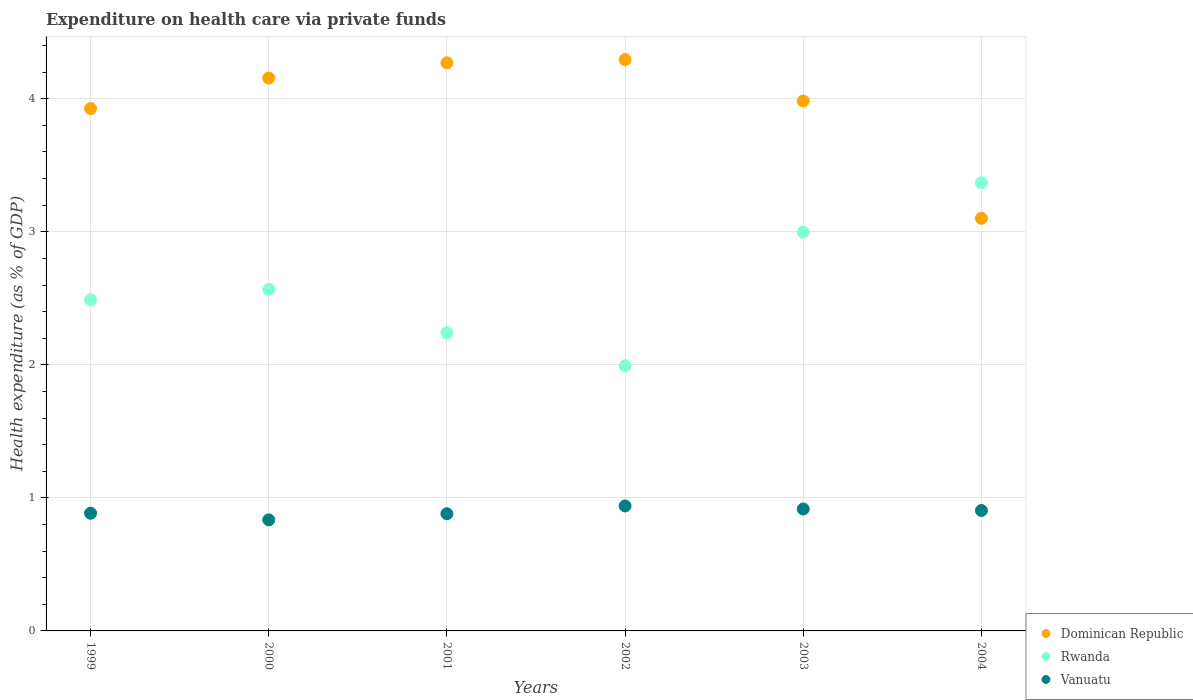Is the number of dotlines equal to the number of legend labels?
Offer a terse response. Yes. What is the expenditure made on health care in Rwanda in 2003?
Provide a short and direct response. 3. Across all years, what is the maximum expenditure made on health care in Dominican Republic?
Give a very brief answer. 4.29. Across all years, what is the minimum expenditure made on health care in Rwanda?
Give a very brief answer. 1.99. What is the total expenditure made on health care in Rwanda in the graph?
Keep it short and to the point. 15.66. What is the difference between the expenditure made on health care in Dominican Republic in 1999 and that in 2004?
Provide a short and direct response. 0.82. What is the difference between the expenditure made on health care in Dominican Republic in 2003 and the expenditure made on health care in Rwanda in 2000?
Make the answer very short. 1.42. What is the average expenditure made on health care in Rwanda per year?
Give a very brief answer. 2.61. In the year 1999, what is the difference between the expenditure made on health care in Dominican Republic and expenditure made on health care in Rwanda?
Give a very brief answer. 1.44. What is the ratio of the expenditure made on health care in Rwanda in 1999 to that in 2004?
Give a very brief answer. 0.74. Is the expenditure made on health care in Vanuatu in 2000 less than that in 2003?
Ensure brevity in your answer.  Yes. Is the difference between the expenditure made on health care in Dominican Republic in 2001 and 2003 greater than the difference between the expenditure made on health care in Rwanda in 2001 and 2003?
Provide a short and direct response. Yes. What is the difference between the highest and the second highest expenditure made on health care in Rwanda?
Provide a short and direct response. 0.37. What is the difference between the highest and the lowest expenditure made on health care in Vanuatu?
Provide a short and direct response. 0.1. Is the sum of the expenditure made on health care in Vanuatu in 1999 and 2003 greater than the maximum expenditure made on health care in Rwanda across all years?
Provide a short and direct response. No. Is the expenditure made on health care in Dominican Republic strictly greater than the expenditure made on health care in Vanuatu over the years?
Your answer should be compact. Yes. How many dotlines are there?
Offer a very short reply. 3. How many years are there in the graph?
Offer a very short reply. 6. What is the difference between two consecutive major ticks on the Y-axis?
Give a very brief answer. 1. Are the values on the major ticks of Y-axis written in scientific E-notation?
Your answer should be compact. No. Where does the legend appear in the graph?
Make the answer very short. Bottom right. What is the title of the graph?
Your answer should be compact. Expenditure on health care via private funds. Does "Monaco" appear as one of the legend labels in the graph?
Your response must be concise. No. What is the label or title of the Y-axis?
Offer a very short reply. Health expenditure (as % of GDP). What is the Health expenditure (as % of GDP) in Dominican Republic in 1999?
Keep it short and to the point. 3.93. What is the Health expenditure (as % of GDP) of Rwanda in 1999?
Ensure brevity in your answer.  2.49. What is the Health expenditure (as % of GDP) in Vanuatu in 1999?
Offer a very short reply. 0.88. What is the Health expenditure (as % of GDP) in Dominican Republic in 2000?
Offer a very short reply. 4.16. What is the Health expenditure (as % of GDP) in Rwanda in 2000?
Provide a short and direct response. 2.57. What is the Health expenditure (as % of GDP) of Vanuatu in 2000?
Provide a short and direct response. 0.83. What is the Health expenditure (as % of GDP) in Dominican Republic in 2001?
Provide a short and direct response. 4.27. What is the Health expenditure (as % of GDP) of Rwanda in 2001?
Give a very brief answer. 2.24. What is the Health expenditure (as % of GDP) in Vanuatu in 2001?
Your response must be concise. 0.88. What is the Health expenditure (as % of GDP) of Dominican Republic in 2002?
Provide a succinct answer. 4.29. What is the Health expenditure (as % of GDP) of Rwanda in 2002?
Give a very brief answer. 1.99. What is the Health expenditure (as % of GDP) of Vanuatu in 2002?
Your response must be concise. 0.94. What is the Health expenditure (as % of GDP) of Dominican Republic in 2003?
Your answer should be very brief. 3.98. What is the Health expenditure (as % of GDP) in Rwanda in 2003?
Your answer should be very brief. 3. What is the Health expenditure (as % of GDP) in Vanuatu in 2003?
Your answer should be very brief. 0.92. What is the Health expenditure (as % of GDP) in Dominican Republic in 2004?
Provide a short and direct response. 3.1. What is the Health expenditure (as % of GDP) in Rwanda in 2004?
Ensure brevity in your answer.  3.37. What is the Health expenditure (as % of GDP) in Vanuatu in 2004?
Provide a succinct answer. 0.91. Across all years, what is the maximum Health expenditure (as % of GDP) in Dominican Republic?
Give a very brief answer. 4.29. Across all years, what is the maximum Health expenditure (as % of GDP) of Rwanda?
Ensure brevity in your answer.  3.37. Across all years, what is the maximum Health expenditure (as % of GDP) in Vanuatu?
Ensure brevity in your answer.  0.94. Across all years, what is the minimum Health expenditure (as % of GDP) of Dominican Republic?
Provide a short and direct response. 3.1. Across all years, what is the minimum Health expenditure (as % of GDP) of Rwanda?
Your answer should be compact. 1.99. Across all years, what is the minimum Health expenditure (as % of GDP) of Vanuatu?
Give a very brief answer. 0.83. What is the total Health expenditure (as % of GDP) in Dominican Republic in the graph?
Your response must be concise. 23.73. What is the total Health expenditure (as % of GDP) in Rwanda in the graph?
Provide a succinct answer. 15.66. What is the total Health expenditure (as % of GDP) of Vanuatu in the graph?
Provide a succinct answer. 5.36. What is the difference between the Health expenditure (as % of GDP) of Dominican Republic in 1999 and that in 2000?
Provide a short and direct response. -0.23. What is the difference between the Health expenditure (as % of GDP) of Rwanda in 1999 and that in 2000?
Provide a short and direct response. -0.08. What is the difference between the Health expenditure (as % of GDP) in Vanuatu in 1999 and that in 2000?
Give a very brief answer. 0.05. What is the difference between the Health expenditure (as % of GDP) of Dominican Republic in 1999 and that in 2001?
Your response must be concise. -0.34. What is the difference between the Health expenditure (as % of GDP) of Rwanda in 1999 and that in 2001?
Offer a terse response. 0.25. What is the difference between the Health expenditure (as % of GDP) of Vanuatu in 1999 and that in 2001?
Provide a short and direct response. 0. What is the difference between the Health expenditure (as % of GDP) of Dominican Republic in 1999 and that in 2002?
Offer a terse response. -0.37. What is the difference between the Health expenditure (as % of GDP) of Rwanda in 1999 and that in 2002?
Provide a short and direct response. 0.5. What is the difference between the Health expenditure (as % of GDP) in Vanuatu in 1999 and that in 2002?
Your answer should be compact. -0.05. What is the difference between the Health expenditure (as % of GDP) in Dominican Republic in 1999 and that in 2003?
Your answer should be very brief. -0.06. What is the difference between the Health expenditure (as % of GDP) in Rwanda in 1999 and that in 2003?
Provide a succinct answer. -0.51. What is the difference between the Health expenditure (as % of GDP) of Vanuatu in 1999 and that in 2003?
Provide a succinct answer. -0.03. What is the difference between the Health expenditure (as % of GDP) of Dominican Republic in 1999 and that in 2004?
Keep it short and to the point. 0.82. What is the difference between the Health expenditure (as % of GDP) of Rwanda in 1999 and that in 2004?
Give a very brief answer. -0.88. What is the difference between the Health expenditure (as % of GDP) of Vanuatu in 1999 and that in 2004?
Provide a short and direct response. -0.02. What is the difference between the Health expenditure (as % of GDP) of Dominican Republic in 2000 and that in 2001?
Your answer should be very brief. -0.11. What is the difference between the Health expenditure (as % of GDP) in Rwanda in 2000 and that in 2001?
Ensure brevity in your answer.  0.33. What is the difference between the Health expenditure (as % of GDP) of Vanuatu in 2000 and that in 2001?
Offer a very short reply. -0.05. What is the difference between the Health expenditure (as % of GDP) in Dominican Republic in 2000 and that in 2002?
Give a very brief answer. -0.14. What is the difference between the Health expenditure (as % of GDP) in Rwanda in 2000 and that in 2002?
Ensure brevity in your answer.  0.57. What is the difference between the Health expenditure (as % of GDP) of Vanuatu in 2000 and that in 2002?
Keep it short and to the point. -0.1. What is the difference between the Health expenditure (as % of GDP) of Dominican Republic in 2000 and that in 2003?
Your answer should be compact. 0.17. What is the difference between the Health expenditure (as % of GDP) in Rwanda in 2000 and that in 2003?
Your answer should be compact. -0.43. What is the difference between the Health expenditure (as % of GDP) of Vanuatu in 2000 and that in 2003?
Give a very brief answer. -0.08. What is the difference between the Health expenditure (as % of GDP) in Dominican Republic in 2000 and that in 2004?
Your answer should be compact. 1.05. What is the difference between the Health expenditure (as % of GDP) of Rwanda in 2000 and that in 2004?
Ensure brevity in your answer.  -0.8. What is the difference between the Health expenditure (as % of GDP) in Vanuatu in 2000 and that in 2004?
Ensure brevity in your answer.  -0.07. What is the difference between the Health expenditure (as % of GDP) of Dominican Republic in 2001 and that in 2002?
Your answer should be compact. -0.02. What is the difference between the Health expenditure (as % of GDP) in Rwanda in 2001 and that in 2002?
Give a very brief answer. 0.25. What is the difference between the Health expenditure (as % of GDP) in Vanuatu in 2001 and that in 2002?
Offer a very short reply. -0.06. What is the difference between the Health expenditure (as % of GDP) in Dominican Republic in 2001 and that in 2003?
Make the answer very short. 0.29. What is the difference between the Health expenditure (as % of GDP) of Rwanda in 2001 and that in 2003?
Your answer should be compact. -0.76. What is the difference between the Health expenditure (as % of GDP) of Vanuatu in 2001 and that in 2003?
Keep it short and to the point. -0.04. What is the difference between the Health expenditure (as % of GDP) of Dominican Republic in 2001 and that in 2004?
Give a very brief answer. 1.17. What is the difference between the Health expenditure (as % of GDP) of Rwanda in 2001 and that in 2004?
Ensure brevity in your answer.  -1.13. What is the difference between the Health expenditure (as % of GDP) of Vanuatu in 2001 and that in 2004?
Make the answer very short. -0.02. What is the difference between the Health expenditure (as % of GDP) in Dominican Republic in 2002 and that in 2003?
Offer a very short reply. 0.31. What is the difference between the Health expenditure (as % of GDP) of Rwanda in 2002 and that in 2003?
Give a very brief answer. -1. What is the difference between the Health expenditure (as % of GDP) in Vanuatu in 2002 and that in 2003?
Give a very brief answer. 0.02. What is the difference between the Health expenditure (as % of GDP) in Dominican Republic in 2002 and that in 2004?
Give a very brief answer. 1.19. What is the difference between the Health expenditure (as % of GDP) in Rwanda in 2002 and that in 2004?
Your response must be concise. -1.38. What is the difference between the Health expenditure (as % of GDP) in Vanuatu in 2002 and that in 2004?
Provide a short and direct response. 0.03. What is the difference between the Health expenditure (as % of GDP) of Dominican Republic in 2003 and that in 2004?
Provide a succinct answer. 0.88. What is the difference between the Health expenditure (as % of GDP) of Rwanda in 2003 and that in 2004?
Give a very brief answer. -0.37. What is the difference between the Health expenditure (as % of GDP) of Vanuatu in 2003 and that in 2004?
Your answer should be compact. 0.01. What is the difference between the Health expenditure (as % of GDP) in Dominican Republic in 1999 and the Health expenditure (as % of GDP) in Rwanda in 2000?
Make the answer very short. 1.36. What is the difference between the Health expenditure (as % of GDP) in Dominican Republic in 1999 and the Health expenditure (as % of GDP) in Vanuatu in 2000?
Provide a short and direct response. 3.09. What is the difference between the Health expenditure (as % of GDP) of Rwanda in 1999 and the Health expenditure (as % of GDP) of Vanuatu in 2000?
Keep it short and to the point. 1.65. What is the difference between the Health expenditure (as % of GDP) in Dominican Republic in 1999 and the Health expenditure (as % of GDP) in Rwanda in 2001?
Make the answer very short. 1.69. What is the difference between the Health expenditure (as % of GDP) in Dominican Republic in 1999 and the Health expenditure (as % of GDP) in Vanuatu in 2001?
Ensure brevity in your answer.  3.05. What is the difference between the Health expenditure (as % of GDP) of Rwanda in 1999 and the Health expenditure (as % of GDP) of Vanuatu in 2001?
Provide a short and direct response. 1.61. What is the difference between the Health expenditure (as % of GDP) of Dominican Republic in 1999 and the Health expenditure (as % of GDP) of Rwanda in 2002?
Your response must be concise. 1.93. What is the difference between the Health expenditure (as % of GDP) in Dominican Republic in 1999 and the Health expenditure (as % of GDP) in Vanuatu in 2002?
Provide a short and direct response. 2.99. What is the difference between the Health expenditure (as % of GDP) of Rwanda in 1999 and the Health expenditure (as % of GDP) of Vanuatu in 2002?
Offer a terse response. 1.55. What is the difference between the Health expenditure (as % of GDP) of Dominican Republic in 1999 and the Health expenditure (as % of GDP) of Rwanda in 2003?
Make the answer very short. 0.93. What is the difference between the Health expenditure (as % of GDP) in Dominican Republic in 1999 and the Health expenditure (as % of GDP) in Vanuatu in 2003?
Provide a short and direct response. 3.01. What is the difference between the Health expenditure (as % of GDP) of Rwanda in 1999 and the Health expenditure (as % of GDP) of Vanuatu in 2003?
Provide a succinct answer. 1.57. What is the difference between the Health expenditure (as % of GDP) of Dominican Republic in 1999 and the Health expenditure (as % of GDP) of Rwanda in 2004?
Your response must be concise. 0.56. What is the difference between the Health expenditure (as % of GDP) of Dominican Republic in 1999 and the Health expenditure (as % of GDP) of Vanuatu in 2004?
Ensure brevity in your answer.  3.02. What is the difference between the Health expenditure (as % of GDP) of Rwanda in 1999 and the Health expenditure (as % of GDP) of Vanuatu in 2004?
Ensure brevity in your answer.  1.58. What is the difference between the Health expenditure (as % of GDP) in Dominican Republic in 2000 and the Health expenditure (as % of GDP) in Rwanda in 2001?
Your answer should be very brief. 1.91. What is the difference between the Health expenditure (as % of GDP) of Dominican Republic in 2000 and the Health expenditure (as % of GDP) of Vanuatu in 2001?
Provide a short and direct response. 3.27. What is the difference between the Health expenditure (as % of GDP) of Rwanda in 2000 and the Health expenditure (as % of GDP) of Vanuatu in 2001?
Provide a short and direct response. 1.69. What is the difference between the Health expenditure (as % of GDP) in Dominican Republic in 2000 and the Health expenditure (as % of GDP) in Rwanda in 2002?
Provide a short and direct response. 2.16. What is the difference between the Health expenditure (as % of GDP) of Dominican Republic in 2000 and the Health expenditure (as % of GDP) of Vanuatu in 2002?
Provide a short and direct response. 3.22. What is the difference between the Health expenditure (as % of GDP) in Rwanda in 2000 and the Health expenditure (as % of GDP) in Vanuatu in 2002?
Ensure brevity in your answer.  1.63. What is the difference between the Health expenditure (as % of GDP) of Dominican Republic in 2000 and the Health expenditure (as % of GDP) of Rwanda in 2003?
Ensure brevity in your answer.  1.16. What is the difference between the Health expenditure (as % of GDP) in Dominican Republic in 2000 and the Health expenditure (as % of GDP) in Vanuatu in 2003?
Your answer should be compact. 3.24. What is the difference between the Health expenditure (as % of GDP) of Rwanda in 2000 and the Health expenditure (as % of GDP) of Vanuatu in 2003?
Offer a very short reply. 1.65. What is the difference between the Health expenditure (as % of GDP) in Dominican Republic in 2000 and the Health expenditure (as % of GDP) in Rwanda in 2004?
Your answer should be compact. 0.79. What is the difference between the Health expenditure (as % of GDP) in Dominican Republic in 2000 and the Health expenditure (as % of GDP) in Vanuatu in 2004?
Your response must be concise. 3.25. What is the difference between the Health expenditure (as % of GDP) of Rwanda in 2000 and the Health expenditure (as % of GDP) of Vanuatu in 2004?
Make the answer very short. 1.66. What is the difference between the Health expenditure (as % of GDP) of Dominican Republic in 2001 and the Health expenditure (as % of GDP) of Rwanda in 2002?
Your answer should be very brief. 2.28. What is the difference between the Health expenditure (as % of GDP) of Dominican Republic in 2001 and the Health expenditure (as % of GDP) of Vanuatu in 2002?
Your response must be concise. 3.33. What is the difference between the Health expenditure (as % of GDP) of Rwanda in 2001 and the Health expenditure (as % of GDP) of Vanuatu in 2002?
Keep it short and to the point. 1.3. What is the difference between the Health expenditure (as % of GDP) in Dominican Republic in 2001 and the Health expenditure (as % of GDP) in Rwanda in 2003?
Make the answer very short. 1.27. What is the difference between the Health expenditure (as % of GDP) in Dominican Republic in 2001 and the Health expenditure (as % of GDP) in Vanuatu in 2003?
Offer a terse response. 3.35. What is the difference between the Health expenditure (as % of GDP) in Rwanda in 2001 and the Health expenditure (as % of GDP) in Vanuatu in 2003?
Keep it short and to the point. 1.32. What is the difference between the Health expenditure (as % of GDP) in Dominican Republic in 2001 and the Health expenditure (as % of GDP) in Rwanda in 2004?
Your response must be concise. 0.9. What is the difference between the Health expenditure (as % of GDP) in Dominican Republic in 2001 and the Health expenditure (as % of GDP) in Vanuatu in 2004?
Provide a short and direct response. 3.37. What is the difference between the Health expenditure (as % of GDP) of Rwanda in 2001 and the Health expenditure (as % of GDP) of Vanuatu in 2004?
Offer a very short reply. 1.34. What is the difference between the Health expenditure (as % of GDP) of Dominican Republic in 2002 and the Health expenditure (as % of GDP) of Rwanda in 2003?
Your answer should be compact. 1.3. What is the difference between the Health expenditure (as % of GDP) of Dominican Republic in 2002 and the Health expenditure (as % of GDP) of Vanuatu in 2003?
Ensure brevity in your answer.  3.38. What is the difference between the Health expenditure (as % of GDP) of Rwanda in 2002 and the Health expenditure (as % of GDP) of Vanuatu in 2003?
Your response must be concise. 1.08. What is the difference between the Health expenditure (as % of GDP) in Dominican Republic in 2002 and the Health expenditure (as % of GDP) in Rwanda in 2004?
Ensure brevity in your answer.  0.93. What is the difference between the Health expenditure (as % of GDP) in Dominican Republic in 2002 and the Health expenditure (as % of GDP) in Vanuatu in 2004?
Make the answer very short. 3.39. What is the difference between the Health expenditure (as % of GDP) of Rwanda in 2002 and the Health expenditure (as % of GDP) of Vanuatu in 2004?
Your response must be concise. 1.09. What is the difference between the Health expenditure (as % of GDP) in Dominican Republic in 2003 and the Health expenditure (as % of GDP) in Rwanda in 2004?
Offer a very short reply. 0.61. What is the difference between the Health expenditure (as % of GDP) in Dominican Republic in 2003 and the Health expenditure (as % of GDP) in Vanuatu in 2004?
Make the answer very short. 3.08. What is the difference between the Health expenditure (as % of GDP) in Rwanda in 2003 and the Health expenditure (as % of GDP) in Vanuatu in 2004?
Offer a very short reply. 2.09. What is the average Health expenditure (as % of GDP) in Dominican Republic per year?
Your answer should be compact. 3.96. What is the average Health expenditure (as % of GDP) of Rwanda per year?
Make the answer very short. 2.61. What is the average Health expenditure (as % of GDP) of Vanuatu per year?
Your answer should be compact. 0.89. In the year 1999, what is the difference between the Health expenditure (as % of GDP) in Dominican Republic and Health expenditure (as % of GDP) in Rwanda?
Make the answer very short. 1.44. In the year 1999, what is the difference between the Health expenditure (as % of GDP) of Dominican Republic and Health expenditure (as % of GDP) of Vanuatu?
Make the answer very short. 3.04. In the year 1999, what is the difference between the Health expenditure (as % of GDP) of Rwanda and Health expenditure (as % of GDP) of Vanuatu?
Your answer should be very brief. 1.6. In the year 2000, what is the difference between the Health expenditure (as % of GDP) in Dominican Republic and Health expenditure (as % of GDP) in Rwanda?
Provide a short and direct response. 1.59. In the year 2000, what is the difference between the Health expenditure (as % of GDP) in Dominican Republic and Health expenditure (as % of GDP) in Vanuatu?
Offer a very short reply. 3.32. In the year 2000, what is the difference between the Health expenditure (as % of GDP) of Rwanda and Health expenditure (as % of GDP) of Vanuatu?
Offer a very short reply. 1.73. In the year 2001, what is the difference between the Health expenditure (as % of GDP) in Dominican Republic and Health expenditure (as % of GDP) in Rwanda?
Give a very brief answer. 2.03. In the year 2001, what is the difference between the Health expenditure (as % of GDP) of Dominican Republic and Health expenditure (as % of GDP) of Vanuatu?
Your answer should be very brief. 3.39. In the year 2001, what is the difference between the Health expenditure (as % of GDP) of Rwanda and Health expenditure (as % of GDP) of Vanuatu?
Ensure brevity in your answer.  1.36. In the year 2002, what is the difference between the Health expenditure (as % of GDP) in Dominican Republic and Health expenditure (as % of GDP) in Rwanda?
Offer a terse response. 2.3. In the year 2002, what is the difference between the Health expenditure (as % of GDP) of Dominican Republic and Health expenditure (as % of GDP) of Vanuatu?
Ensure brevity in your answer.  3.36. In the year 2002, what is the difference between the Health expenditure (as % of GDP) of Rwanda and Health expenditure (as % of GDP) of Vanuatu?
Your response must be concise. 1.05. In the year 2003, what is the difference between the Health expenditure (as % of GDP) of Dominican Republic and Health expenditure (as % of GDP) of Rwanda?
Provide a succinct answer. 0.99. In the year 2003, what is the difference between the Health expenditure (as % of GDP) in Dominican Republic and Health expenditure (as % of GDP) in Vanuatu?
Give a very brief answer. 3.07. In the year 2003, what is the difference between the Health expenditure (as % of GDP) of Rwanda and Health expenditure (as % of GDP) of Vanuatu?
Your answer should be very brief. 2.08. In the year 2004, what is the difference between the Health expenditure (as % of GDP) in Dominican Republic and Health expenditure (as % of GDP) in Rwanda?
Provide a short and direct response. -0.27. In the year 2004, what is the difference between the Health expenditure (as % of GDP) in Dominican Republic and Health expenditure (as % of GDP) in Vanuatu?
Provide a succinct answer. 2.2. In the year 2004, what is the difference between the Health expenditure (as % of GDP) in Rwanda and Health expenditure (as % of GDP) in Vanuatu?
Your answer should be very brief. 2.46. What is the ratio of the Health expenditure (as % of GDP) in Dominican Republic in 1999 to that in 2000?
Offer a very short reply. 0.94. What is the ratio of the Health expenditure (as % of GDP) of Rwanda in 1999 to that in 2000?
Provide a succinct answer. 0.97. What is the ratio of the Health expenditure (as % of GDP) in Vanuatu in 1999 to that in 2000?
Your answer should be compact. 1.06. What is the ratio of the Health expenditure (as % of GDP) in Dominican Republic in 1999 to that in 2001?
Provide a succinct answer. 0.92. What is the ratio of the Health expenditure (as % of GDP) in Rwanda in 1999 to that in 2001?
Your response must be concise. 1.11. What is the ratio of the Health expenditure (as % of GDP) of Vanuatu in 1999 to that in 2001?
Make the answer very short. 1. What is the ratio of the Health expenditure (as % of GDP) of Dominican Republic in 1999 to that in 2002?
Your response must be concise. 0.91. What is the ratio of the Health expenditure (as % of GDP) of Rwanda in 1999 to that in 2002?
Give a very brief answer. 1.25. What is the ratio of the Health expenditure (as % of GDP) of Vanuatu in 1999 to that in 2002?
Provide a succinct answer. 0.94. What is the ratio of the Health expenditure (as % of GDP) of Dominican Republic in 1999 to that in 2003?
Provide a short and direct response. 0.99. What is the ratio of the Health expenditure (as % of GDP) in Rwanda in 1999 to that in 2003?
Your response must be concise. 0.83. What is the ratio of the Health expenditure (as % of GDP) of Vanuatu in 1999 to that in 2003?
Give a very brief answer. 0.97. What is the ratio of the Health expenditure (as % of GDP) in Dominican Republic in 1999 to that in 2004?
Offer a very short reply. 1.27. What is the ratio of the Health expenditure (as % of GDP) in Rwanda in 1999 to that in 2004?
Your response must be concise. 0.74. What is the ratio of the Health expenditure (as % of GDP) of Vanuatu in 1999 to that in 2004?
Make the answer very short. 0.98. What is the ratio of the Health expenditure (as % of GDP) of Dominican Republic in 2000 to that in 2001?
Provide a short and direct response. 0.97. What is the ratio of the Health expenditure (as % of GDP) of Rwanda in 2000 to that in 2001?
Offer a terse response. 1.15. What is the ratio of the Health expenditure (as % of GDP) in Vanuatu in 2000 to that in 2001?
Your answer should be very brief. 0.95. What is the ratio of the Health expenditure (as % of GDP) of Rwanda in 2000 to that in 2002?
Offer a very short reply. 1.29. What is the ratio of the Health expenditure (as % of GDP) of Vanuatu in 2000 to that in 2002?
Offer a terse response. 0.89. What is the ratio of the Health expenditure (as % of GDP) in Dominican Republic in 2000 to that in 2003?
Give a very brief answer. 1.04. What is the ratio of the Health expenditure (as % of GDP) in Rwanda in 2000 to that in 2003?
Give a very brief answer. 0.86. What is the ratio of the Health expenditure (as % of GDP) of Vanuatu in 2000 to that in 2003?
Your response must be concise. 0.91. What is the ratio of the Health expenditure (as % of GDP) in Dominican Republic in 2000 to that in 2004?
Give a very brief answer. 1.34. What is the ratio of the Health expenditure (as % of GDP) of Rwanda in 2000 to that in 2004?
Your response must be concise. 0.76. What is the ratio of the Health expenditure (as % of GDP) of Vanuatu in 2000 to that in 2004?
Your answer should be very brief. 0.92. What is the ratio of the Health expenditure (as % of GDP) in Rwanda in 2001 to that in 2002?
Your response must be concise. 1.12. What is the ratio of the Health expenditure (as % of GDP) of Vanuatu in 2001 to that in 2002?
Your answer should be very brief. 0.94. What is the ratio of the Health expenditure (as % of GDP) of Dominican Republic in 2001 to that in 2003?
Your answer should be very brief. 1.07. What is the ratio of the Health expenditure (as % of GDP) in Rwanda in 2001 to that in 2003?
Offer a terse response. 0.75. What is the ratio of the Health expenditure (as % of GDP) in Vanuatu in 2001 to that in 2003?
Your answer should be compact. 0.96. What is the ratio of the Health expenditure (as % of GDP) of Dominican Republic in 2001 to that in 2004?
Your answer should be compact. 1.38. What is the ratio of the Health expenditure (as % of GDP) of Rwanda in 2001 to that in 2004?
Offer a very short reply. 0.67. What is the ratio of the Health expenditure (as % of GDP) of Vanuatu in 2001 to that in 2004?
Provide a succinct answer. 0.97. What is the ratio of the Health expenditure (as % of GDP) of Dominican Republic in 2002 to that in 2003?
Your answer should be very brief. 1.08. What is the ratio of the Health expenditure (as % of GDP) in Rwanda in 2002 to that in 2003?
Offer a very short reply. 0.67. What is the ratio of the Health expenditure (as % of GDP) in Vanuatu in 2002 to that in 2003?
Make the answer very short. 1.03. What is the ratio of the Health expenditure (as % of GDP) of Dominican Republic in 2002 to that in 2004?
Your response must be concise. 1.38. What is the ratio of the Health expenditure (as % of GDP) of Rwanda in 2002 to that in 2004?
Offer a very short reply. 0.59. What is the ratio of the Health expenditure (as % of GDP) of Vanuatu in 2002 to that in 2004?
Ensure brevity in your answer.  1.04. What is the ratio of the Health expenditure (as % of GDP) in Dominican Republic in 2003 to that in 2004?
Offer a very short reply. 1.28. What is the ratio of the Health expenditure (as % of GDP) in Rwanda in 2003 to that in 2004?
Make the answer very short. 0.89. What is the ratio of the Health expenditure (as % of GDP) in Vanuatu in 2003 to that in 2004?
Keep it short and to the point. 1.01. What is the difference between the highest and the second highest Health expenditure (as % of GDP) of Dominican Republic?
Offer a terse response. 0.02. What is the difference between the highest and the second highest Health expenditure (as % of GDP) of Rwanda?
Provide a succinct answer. 0.37. What is the difference between the highest and the second highest Health expenditure (as % of GDP) in Vanuatu?
Your answer should be compact. 0.02. What is the difference between the highest and the lowest Health expenditure (as % of GDP) of Dominican Republic?
Provide a succinct answer. 1.19. What is the difference between the highest and the lowest Health expenditure (as % of GDP) in Rwanda?
Give a very brief answer. 1.38. What is the difference between the highest and the lowest Health expenditure (as % of GDP) in Vanuatu?
Provide a short and direct response. 0.1. 